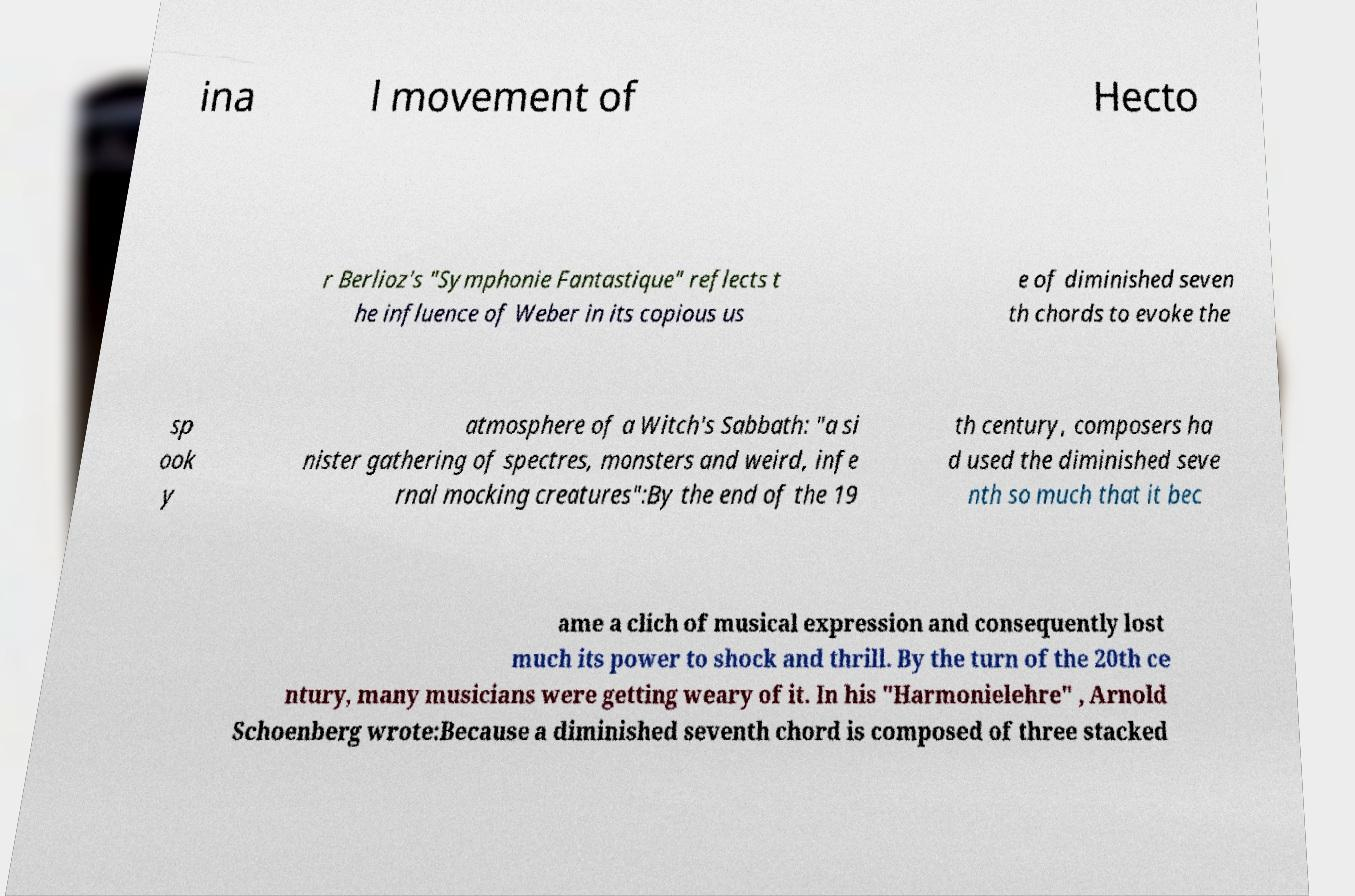Could you assist in decoding the text presented in this image and type it out clearly? ina l movement of Hecto r Berlioz's "Symphonie Fantastique" reflects t he influence of Weber in its copious us e of diminished seven th chords to evoke the sp ook y atmosphere of a Witch's Sabbath: "a si nister gathering of spectres, monsters and weird, infe rnal mocking creatures":By the end of the 19 th century, composers ha d used the diminished seve nth so much that it bec ame a clich of musical expression and consequently lost much its power to shock and thrill. By the turn of the 20th ce ntury, many musicians were getting weary of it. In his "Harmonielehre" , Arnold Schoenberg wrote:Because a diminished seventh chord is composed of three stacked 